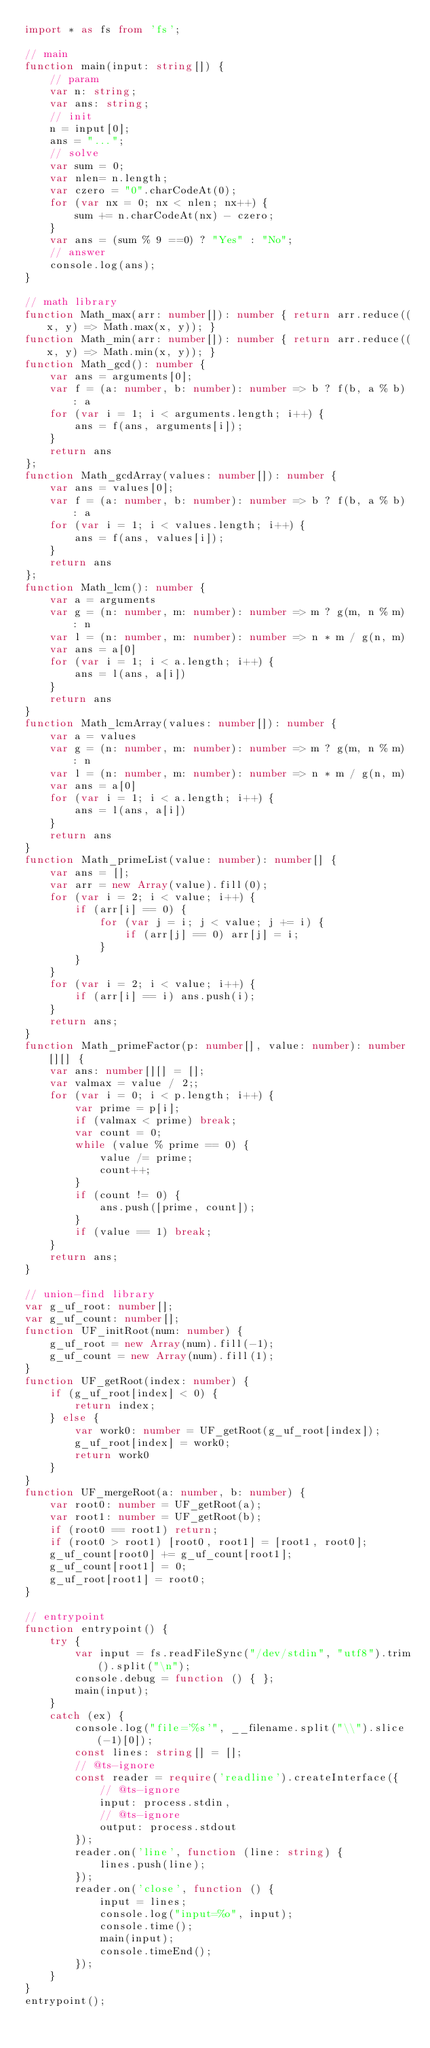Convert code to text. <code><loc_0><loc_0><loc_500><loc_500><_TypeScript_>import * as fs from 'fs';

// main
function main(input: string[]) {
    // param
    var n: string;
    var ans: string;
    // init
    n = input[0];
    ans = "...";
    // solve
    var sum = 0;
    var nlen= n.length;
    var czero = "0".charCodeAt(0);
    for (var nx = 0; nx < nlen; nx++) {
        sum += n.charCodeAt(nx) - czero;
    }
    var ans = (sum % 9 ==0) ? "Yes" : "No";
    // answer
    console.log(ans);
}

// math library
function Math_max(arr: number[]): number { return arr.reduce((x, y) => Math.max(x, y)); }
function Math_min(arr: number[]): number { return arr.reduce((x, y) => Math.min(x, y)); }
function Math_gcd(): number {
    var ans = arguments[0];
    var f = (a: number, b: number): number => b ? f(b, a % b) : a
    for (var i = 1; i < arguments.length; i++) {
        ans = f(ans, arguments[i]);
    }
    return ans
};
function Math_gcdArray(values: number[]): number {
    var ans = values[0];
    var f = (a: number, b: number): number => b ? f(b, a % b) : a
    for (var i = 1; i < values.length; i++) {
        ans = f(ans, values[i]);
    }
    return ans
};
function Math_lcm(): number {
    var a = arguments
    var g = (n: number, m: number): number => m ? g(m, n % m) : n
    var l = (n: number, m: number): number => n * m / g(n, m)
    var ans = a[0]
    for (var i = 1; i < a.length; i++) {
        ans = l(ans, a[i])
    }
    return ans
}
function Math_lcmArray(values: number[]): number {
    var a = values
    var g = (n: number, m: number): number => m ? g(m, n % m) : n
    var l = (n: number, m: number): number => n * m / g(n, m)
    var ans = a[0]
    for (var i = 1; i < a.length; i++) {
        ans = l(ans, a[i])
    }
    return ans
}
function Math_primeList(value: number): number[] {
    var ans = [];
    var arr = new Array(value).fill(0);
    for (var i = 2; i < value; i++) {
        if (arr[i] == 0) {
            for (var j = i; j < value; j += i) {
                if (arr[j] == 0) arr[j] = i;
            }
        }
    }
    for (var i = 2; i < value; i++) {
        if (arr[i] == i) ans.push(i);
    }
    return ans;
}
function Math_primeFactor(p: number[], value: number): number[][] {
    var ans: number[][] = [];
    var valmax = value / 2;;
    for (var i = 0; i < p.length; i++) {
        var prime = p[i];
        if (valmax < prime) break;
        var count = 0;
        while (value % prime == 0) {
            value /= prime;
            count++;
        }
        if (count != 0) {
            ans.push([prime, count]);
        }
        if (value == 1) break;
    }
    return ans;
}

// union-find library
var g_uf_root: number[];
var g_uf_count: number[];
function UF_initRoot(num: number) {
    g_uf_root = new Array(num).fill(-1);
    g_uf_count = new Array(num).fill(1);
}
function UF_getRoot(index: number) {
    if (g_uf_root[index] < 0) {
        return index;
    } else {
        var work0: number = UF_getRoot(g_uf_root[index]);
        g_uf_root[index] = work0;
        return work0
    }
}
function UF_mergeRoot(a: number, b: number) {
    var root0: number = UF_getRoot(a);
    var root1: number = UF_getRoot(b);
    if (root0 == root1) return;
    if (root0 > root1) [root0, root1] = [root1, root0];
    g_uf_count[root0] += g_uf_count[root1];
    g_uf_count[root1] = 0;
    g_uf_root[root1] = root0;
}

// entrypoint
function entrypoint() {
    try {
        var input = fs.readFileSync("/dev/stdin", "utf8").trim().split("\n");
        console.debug = function () { };
        main(input);
    }
    catch (ex) {
        console.log("file='%s'", __filename.split("\\").slice(-1)[0]);
        const lines: string[] = [];
        // @ts-ignore
        const reader = require('readline').createInterface({
            // @ts-ignore
            input: process.stdin,
            // @ts-ignore
            output: process.stdout
        });
        reader.on('line', function (line: string) {
            lines.push(line);
        });
        reader.on('close', function () {
            input = lines;
            console.log("input=%o", input);
            console.time();
            main(input);
            console.timeEnd();
        });
    }
}
entrypoint();
</code> 